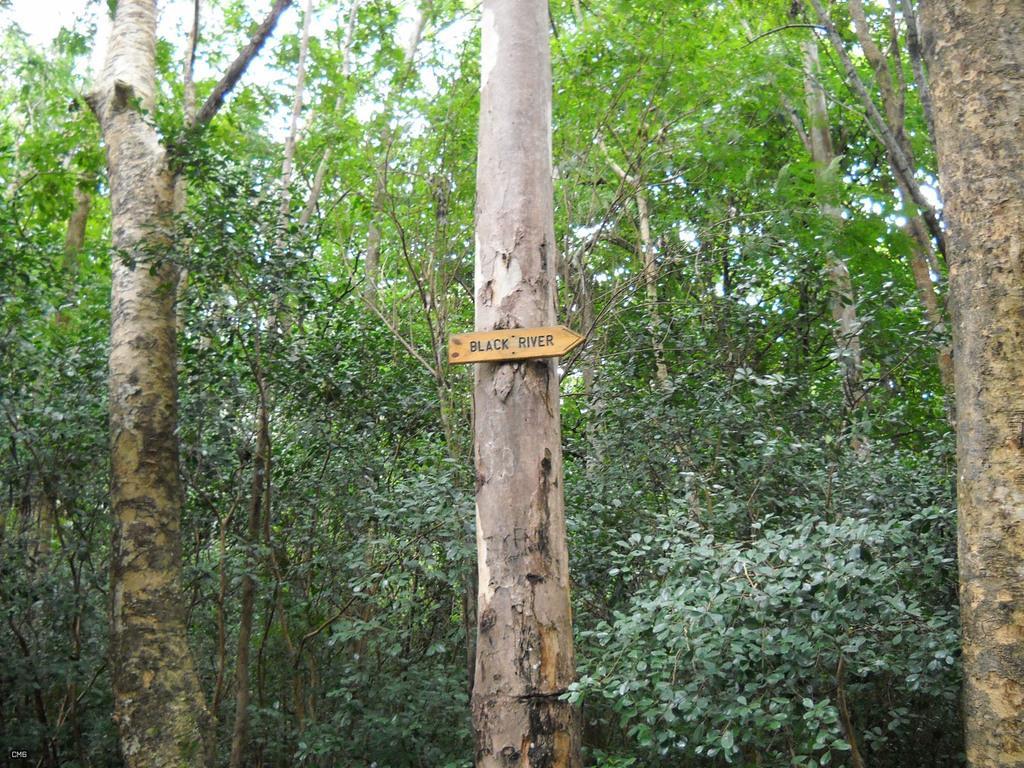Could you give a brief overview of what you see in this image? This picture is clicked outside. In the foreground we can see the plants and trees. In the center there is a wooden object attached to the trunk of the tree and we can see the text on the wooden object. In the background there is a sky. 